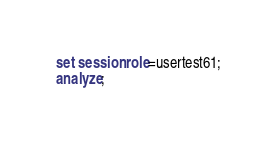Convert code to text. <code><loc_0><loc_0><loc_500><loc_500><_SQL_>set session role=usertest61;
analyze;

</code> 